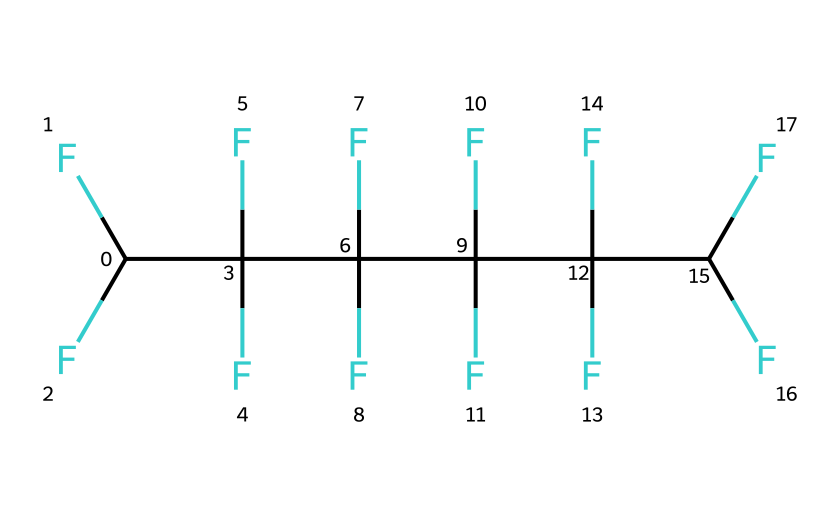How many carbon atoms are in this chemical structure? By examining the SMILES representation, we can identify that each "C" stands for a carbon atom. Counting the occurrences, there are six "C" in total.
Answer: six What type of bonds are present in this chemical structure? The SMILES representation indicates that the carbon atoms are fully fluorinated, suggesting that they are connected by single bonds. A detailed interpretation confirms there are only single bonds between the carbon atoms.
Answer: single bonds What is the main functional group in this chemical? In the structure, the presence of fluorine atoms suggests that this chemical has a perfluorinated carbon chain as its primary functional feature.
Answer: perfluorinated carbon chain How many fluorine atoms are attached to the carbon skeleton? The chemical structure has a total of 18 fluorine atoms indicated by "F" in the SMILES. Counting these will show 18 fluorine atoms surrounding the carbon skeleton.
Answer: eighteen Is this chemical considered hazardous? Given that the chemical structure consists of perfluorinated compounds, they are known to have potential hazardous environmental impacts, particularly regarding bioaccumulation and toxicity.
Answer: yes What might be the primary purpose of this chemical in sweat-wicking fabric? The presence of multiple fluorine atoms suggests that this chemical is likely used to provide water and stain repellency, enhancing the fabric's ability to wick sweat away from the skin.
Answer: water repellent Does this chemical bioaccumulate in organisms? The structure suggests it could bioaccumulate due to its fluorinated nature; perfluorinated compounds are known for their persistence in the environment and tendency to accumulate in living organisms.
Answer: yes 